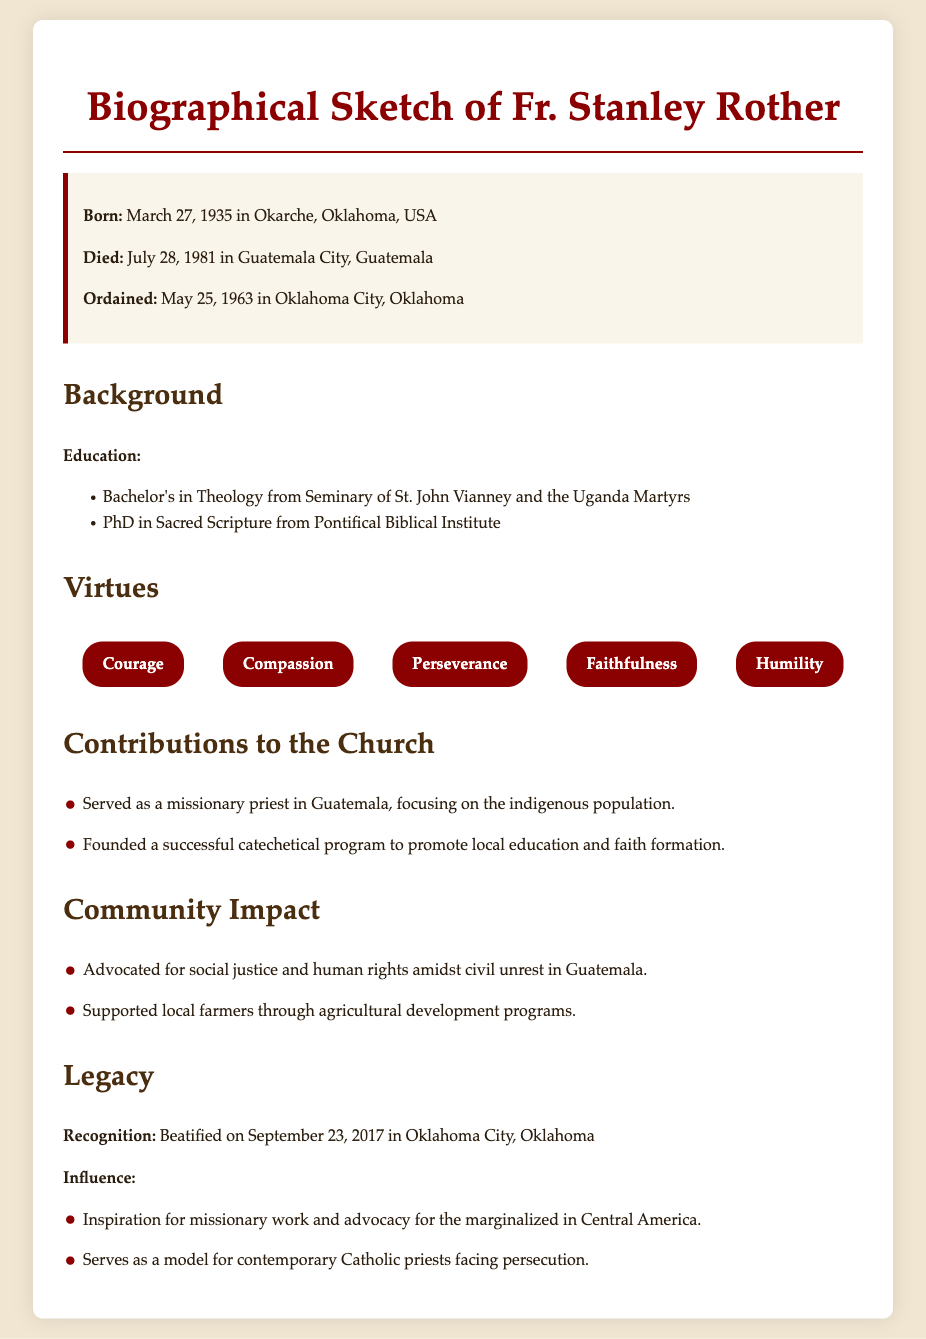What is Fr. Stanley Rother's date of birth? The document states that he was born on March 27, 1935.
Answer: March 27, 1935 What was Fr. Stanley Rother's cause of death? The document mentions that he died in Guatemala City, Guatemala.
Answer: Guatemala City, Guatemala In what year was Fr. Stanley Rother beatified? The document indicates that he was beatified on September 23, 2017.
Answer: 2017 Which degree did Fr. Stanley Rother earn from the Pontifical Biblical Institute? The document states he earned a PhD in Sacred Scripture.
Answer: PhD in Sacred Scripture What virtue is mentioned as part of Fr. Stanley Rother's profile? The document includes "Compassion" as one of the listed virtues.
Answer: Compassion What type of program did Fr. Stanley Rother found in Guatemala? The document states he founded a catechetical program.
Answer: Catechetical program What was one aspect of Fr. Stanley Rother's community impact during his mission? The document mentions he advocated for social justice and human rights.
Answer: Social justice and human rights Which country did Fr. Stanley Rother serve as a missionary? The document specifies that he served in Guatemala.
Answer: Guatemala 